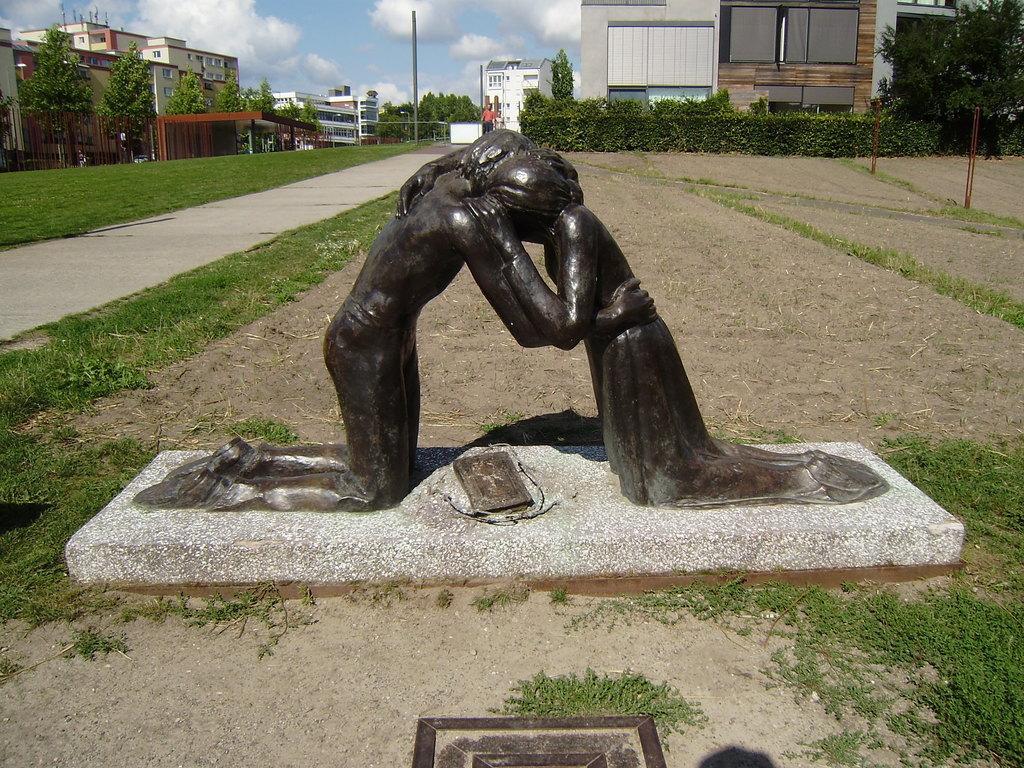Can you describe this image briefly? As we can see in the image in the front there are statues. In the background there is grass, trees, plants, pole and buildings. On the top there is sky and clouds. 